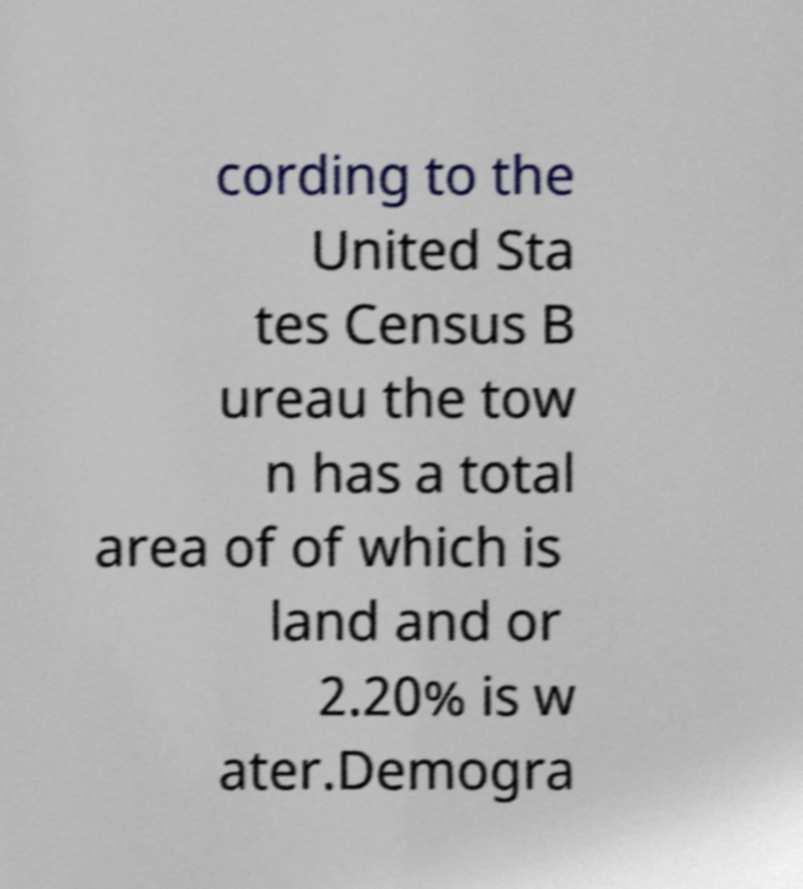Can you accurately transcribe the text from the provided image for me? cording to the United Sta tes Census B ureau the tow n has a total area of of which is land and or 2.20% is w ater.Demogra 